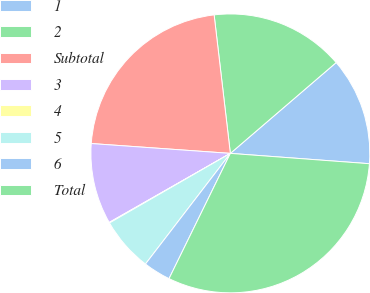<chart> <loc_0><loc_0><loc_500><loc_500><pie_chart><fcel>1<fcel>2<fcel>Subtotal<fcel>3<fcel>4<fcel>5<fcel>6<fcel>Total<nl><fcel>12.47%<fcel>15.57%<fcel>22.02%<fcel>9.37%<fcel>0.07%<fcel>6.27%<fcel>3.17%<fcel>31.07%<nl></chart> 